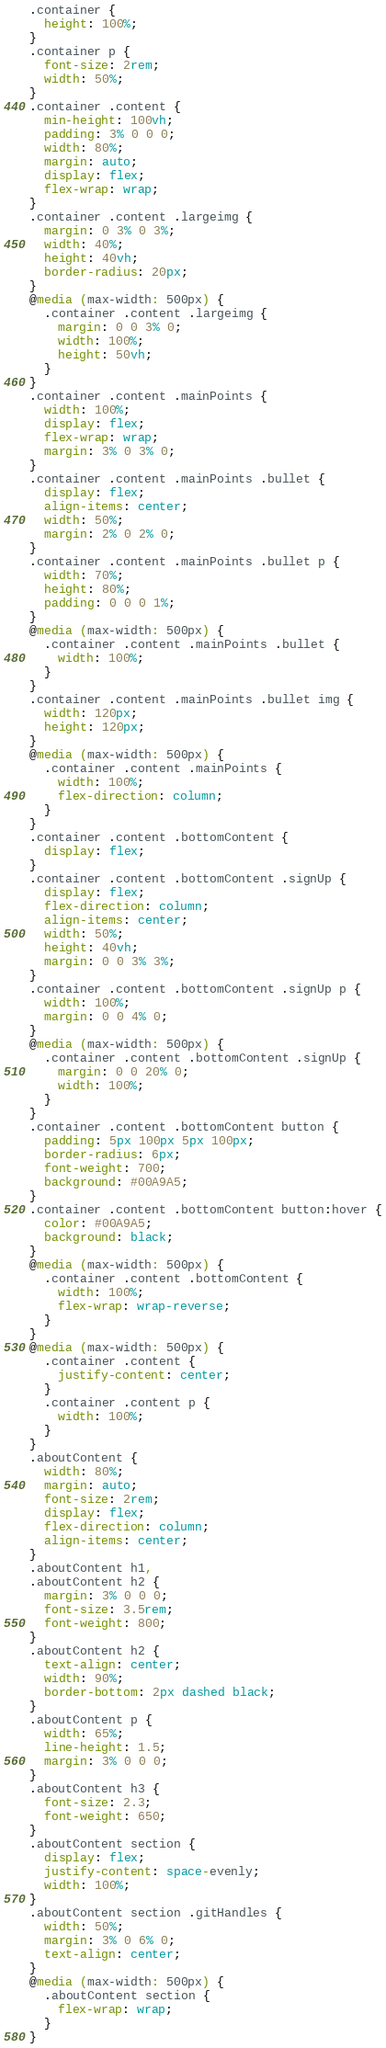Convert code to text. <code><loc_0><loc_0><loc_500><loc_500><_CSS_>.container {
  height: 100%;
}
.container p {
  font-size: 2rem;
  width: 50%;
}
.container .content {
  min-height: 100vh;
  padding: 3% 0 0 0;
  width: 80%;
  margin: auto;
  display: flex;
  flex-wrap: wrap;
}
.container .content .largeimg {
  margin: 0 3% 0 3%;
  width: 40%;
  height: 40vh;
  border-radius: 20px;
}
@media (max-width: 500px) {
  .container .content .largeimg {
    margin: 0 0 3% 0;
    width: 100%;
    height: 50vh;
  }
}
.container .content .mainPoints {
  width: 100%;
  display: flex;
  flex-wrap: wrap;
  margin: 3% 0 3% 0;
}
.container .content .mainPoints .bullet {
  display: flex;
  align-items: center;
  width: 50%;
  margin: 2% 0 2% 0;
}
.container .content .mainPoints .bullet p {
  width: 70%;
  height: 80%;
  padding: 0 0 0 1%;
}
@media (max-width: 500px) {
  .container .content .mainPoints .bullet {
    width: 100%;
  }
}
.container .content .mainPoints .bullet img {
  width: 120px;
  height: 120px;
}
@media (max-width: 500px) {
  .container .content .mainPoints {
    width: 100%;
    flex-direction: column;
  }
}
.container .content .bottomContent {
  display: flex;
}
.container .content .bottomContent .signUp {
  display: flex;
  flex-direction: column;
  align-items: center;
  width: 50%;
  height: 40vh;
  margin: 0 0 3% 3%;
}
.container .content .bottomContent .signUp p {
  width: 100%;
  margin: 0 0 4% 0;
}
@media (max-width: 500px) {
  .container .content .bottomContent .signUp {
    margin: 0 0 20% 0;
    width: 100%;
  }
}
.container .content .bottomContent button {
  padding: 5px 100px 5px 100px;
  border-radius: 6px;
  font-weight: 700;
  background: #00A9A5;
}
.container .content .bottomContent button:hover {
  color: #00A9A5;
  background: black;
}
@media (max-width: 500px) {
  .container .content .bottomContent {
    width: 100%;
    flex-wrap: wrap-reverse;
  }
}
@media (max-width: 500px) {
  .container .content {
    justify-content: center;
  }
  .container .content p {
    width: 100%;
  }
}
.aboutContent {
  width: 80%;
  margin: auto;
  font-size: 2rem;
  display: flex;
  flex-direction: column;
  align-items: center;
}
.aboutContent h1,
.aboutContent h2 {
  margin: 3% 0 0 0;
  font-size: 3.5rem;
  font-weight: 800;
}
.aboutContent h2 {
  text-align: center;
  width: 90%;
  border-bottom: 2px dashed black;
}
.aboutContent p {
  width: 65%;
  line-height: 1.5;
  margin: 3% 0 0 0;
}
.aboutContent h3 {
  font-size: 2.3;
  font-weight: 650;
}
.aboutContent section {
  display: flex;
  justify-content: space-evenly;
  width: 100%;
}
.aboutContent section .gitHandles {
  width: 50%;
  margin: 3% 0 6% 0;
  text-align: center;
}
@media (max-width: 500px) {
  .aboutContent section {
    flex-wrap: wrap;
  }
}
</code> 